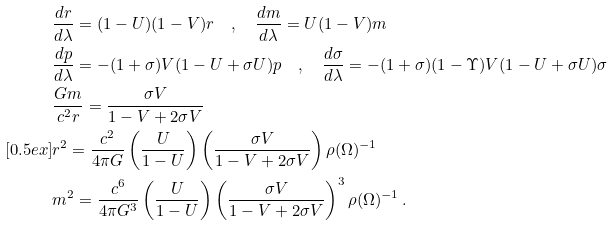<formula> <loc_0><loc_0><loc_500><loc_500>& \frac { d r } { d \lambda } = ( 1 - U ) ( 1 - V ) r \quad , \quad \frac { d m } { d \lambda } = U ( 1 - V ) m \\ & \frac { d p } { d \lambda } = - ( 1 + \sigma ) V ( 1 - U + \sigma U ) p \quad , \quad \frac { d \sigma } { d \lambda } = - ( 1 + \sigma ) ( 1 - \Upsilon ) V ( 1 - U + \sigma U ) \sigma \\ & \frac { G m } { c ^ { 2 } r } = \frac { \sigma V } { 1 - V + 2 \sigma V } \\ [ 0 . 5 e x ] & r ^ { 2 } = \frac { c ^ { 2 } } { 4 \pi G } \left ( \frac { U } { 1 - U } \right ) \left ( \frac { \sigma V } { 1 - V + 2 \sigma V } \right ) \rho ( \Omega ) ^ { - 1 } \\ & m ^ { 2 } = \frac { c ^ { 6 } } { 4 \pi G ^ { 3 } } \left ( \frac { U } { 1 - U } \right ) \left ( \frac { \sigma V } { 1 - V + 2 \sigma V } \right ) ^ { 3 } \rho ( \Omega ) ^ { - 1 } \, .</formula> 